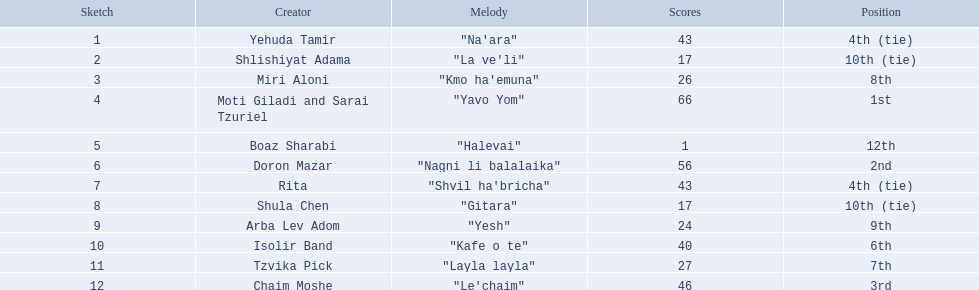Who are all of the artists? Yehuda Tamir, Shlishiyat Adama, Miri Aloni, Moti Giladi and Sarai Tzuriel, Boaz Sharabi, Doron Mazar, Rita, Shula Chen, Arba Lev Adom, Isolir Band, Tzvika Pick, Chaim Moshe. How many points did each score? 43, 17, 26, 66, 1, 56, 43, 17, 24, 40, 27, 46. And which artist had the least amount of points? Boaz Sharabi. 